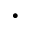Convert formula to latex. <formula><loc_0><loc_0><loc_500><loc_500>\cdot</formula> 